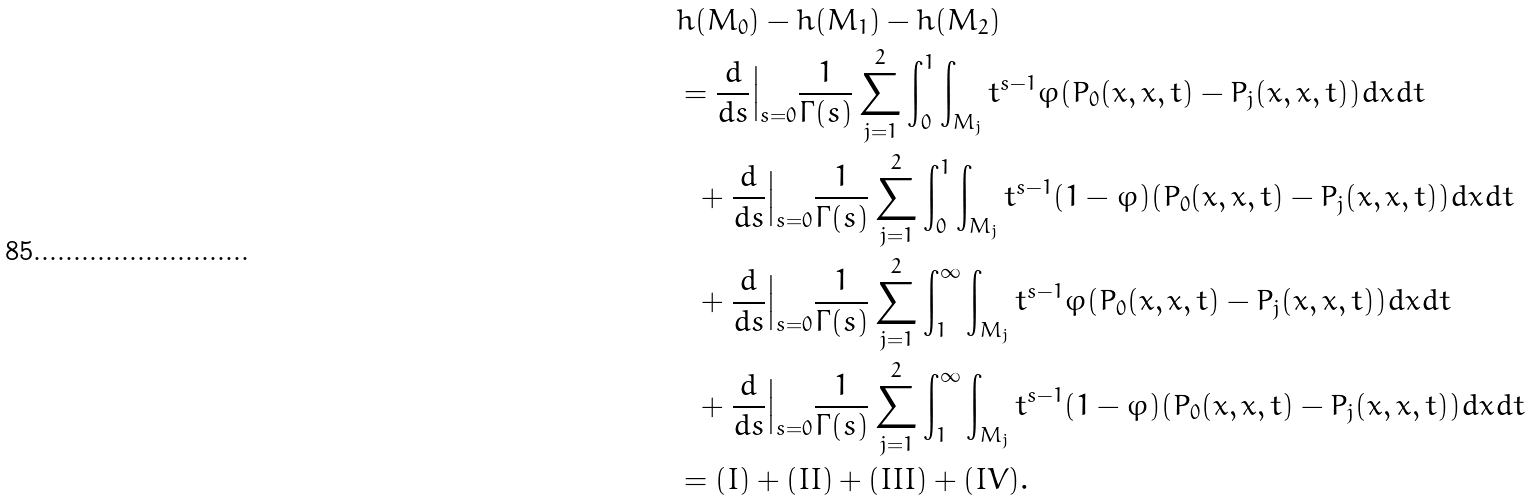Convert formula to latex. <formula><loc_0><loc_0><loc_500><loc_500>& h ( M _ { 0 } ) - h ( M _ { 1 } ) - h ( M _ { 2 } ) \\ & = \frac { d } { d s } \Big { | } _ { s = 0 } \frac { 1 } { \Gamma ( s ) } \sum _ { j = 1 } ^ { 2 } \int _ { 0 } ^ { 1 } \int _ { M _ { j } } t ^ { s - 1 } \varphi ( P _ { 0 } ( x , x , t ) - P _ { j } ( x , x , t ) ) d x d t \\ \ \ & \ \ + \frac { d } { d s } \Big { | } _ { s = 0 } \frac { 1 } { \Gamma ( s ) } \sum _ { j = 1 } ^ { 2 } \int _ { 0 } ^ { 1 } \int _ { M _ { j } } t ^ { s - 1 } ( 1 - \varphi ) ( P _ { 0 } ( x , x , t ) - P _ { j } ( x , x , t ) ) d x d t \\ & \ \ + \frac { d } { d s } \Big { | } _ { s = 0 } \frac { 1 } { \Gamma ( s ) } \sum _ { j = 1 } ^ { 2 } \int _ { 1 } ^ { \infty } \int _ { M _ { j } } t ^ { s - 1 } \varphi ( P _ { 0 } ( x , x , t ) - P _ { j } ( x , x , t ) ) d x d t \\ & \ \ + \frac { d } { d s } \Big { | } _ { s = 0 } \frac { 1 } { \Gamma ( s ) } \sum _ { j = 1 } ^ { 2 } \int _ { 1 } ^ { \infty } \int _ { M _ { j } } t ^ { s - 1 } ( 1 - \varphi ) ( P _ { 0 } ( x , x , t ) - P _ { j } ( x , x , t ) ) d x d t \\ & = ( I ) + ( I I ) + ( I I I ) + ( I V ) .</formula> 